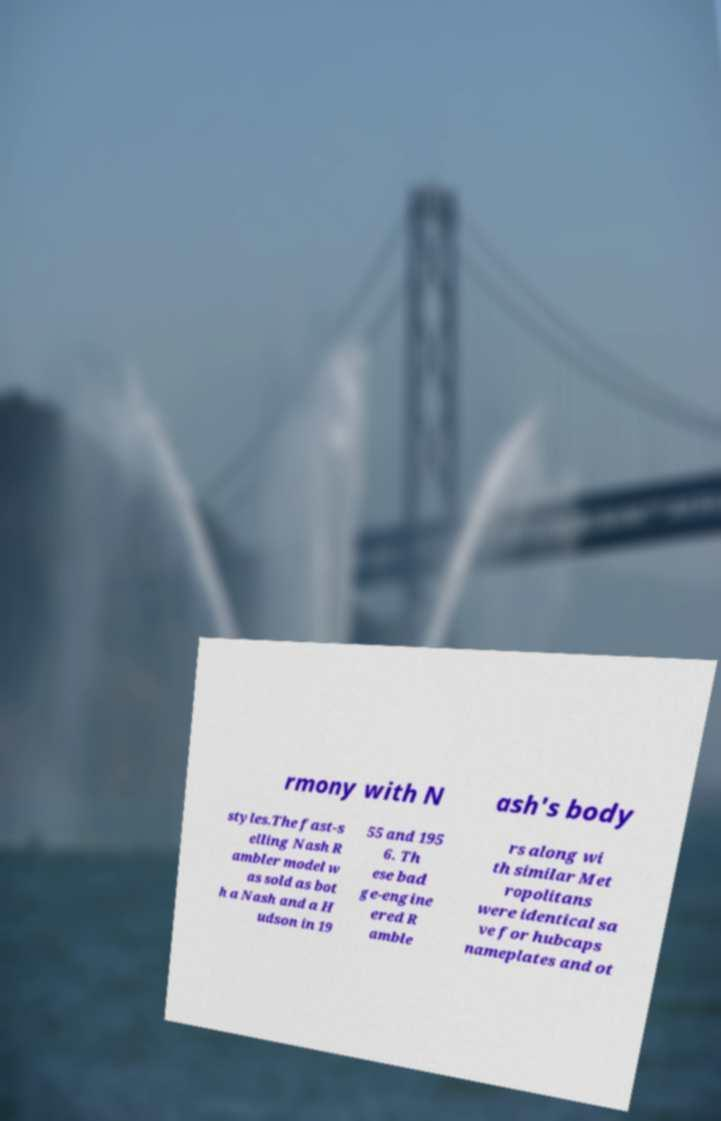Please read and relay the text visible in this image. What does it say? rmony with N ash's body styles.The fast-s elling Nash R ambler model w as sold as bot h a Nash and a H udson in 19 55 and 195 6. Th ese bad ge-engine ered R amble rs along wi th similar Met ropolitans were identical sa ve for hubcaps nameplates and ot 